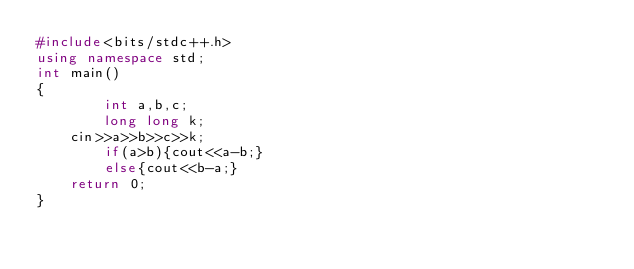Convert code to text. <code><loc_0><loc_0><loc_500><loc_500><_C++_>#include<bits/stdc++.h>
using namespace std;
int main()
{
        int a,b,c;
        long long k;
	cin>>a>>b>>c>>k;
        if(a>b){cout<<a-b;}
        else{cout<<b-a;}
	return 0;
}</code> 